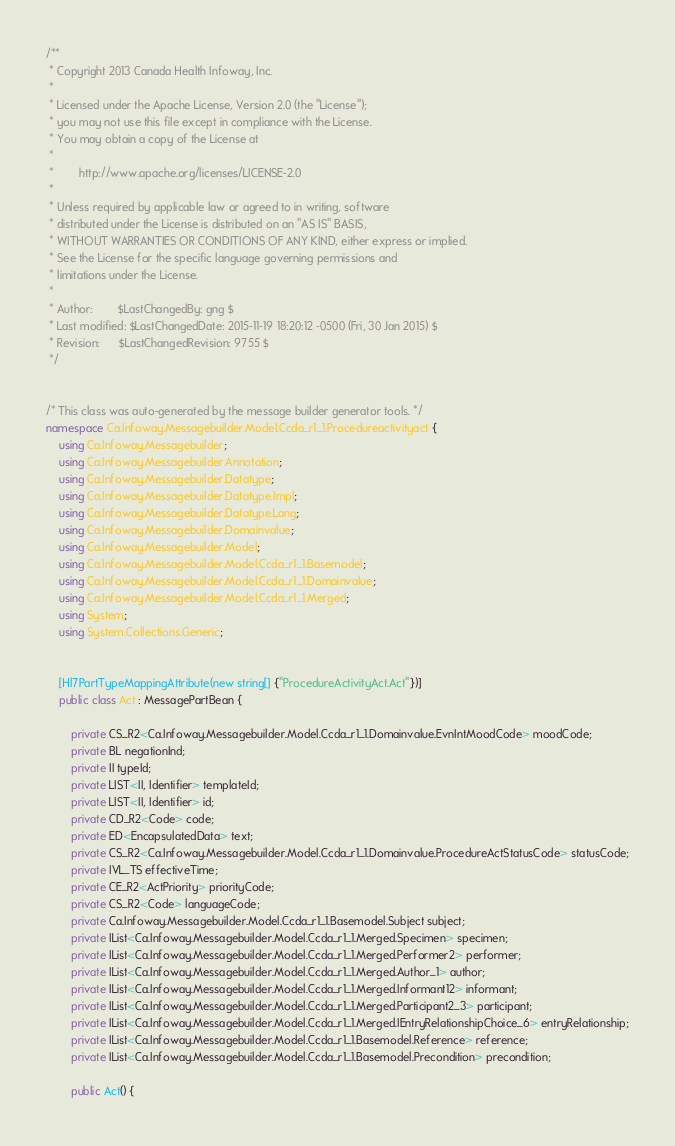Convert code to text. <code><loc_0><loc_0><loc_500><loc_500><_C#_>/**
 * Copyright 2013 Canada Health Infoway, Inc.
 *
 * Licensed under the Apache License, Version 2.0 (the "License");
 * you may not use this file except in compliance with the License.
 * You may obtain a copy of the License at
 *
 *        http://www.apache.org/licenses/LICENSE-2.0
 *
 * Unless required by applicable law or agreed to in writing, software
 * distributed under the License is distributed on an "AS IS" BASIS,
 * WITHOUT WARRANTIES OR CONDITIONS OF ANY KIND, either express or implied.
 * See the License for the specific language governing permissions and
 * limitations under the License.
 *
 * Author:        $LastChangedBy: gng $
 * Last modified: $LastChangedDate: 2015-11-19 18:20:12 -0500 (Fri, 30 Jan 2015) $
 * Revision:      $LastChangedRevision: 9755 $
 */


/* This class was auto-generated by the message builder generator tools. */
namespace Ca.Infoway.Messagebuilder.Model.Ccda_r1_1.Procedureactivityact {
    using Ca.Infoway.Messagebuilder;
    using Ca.Infoway.Messagebuilder.Annotation;
    using Ca.Infoway.Messagebuilder.Datatype;
    using Ca.Infoway.Messagebuilder.Datatype.Impl;
    using Ca.Infoway.Messagebuilder.Datatype.Lang;
    using Ca.Infoway.Messagebuilder.Domainvalue;
    using Ca.Infoway.Messagebuilder.Model;
    using Ca.Infoway.Messagebuilder.Model.Ccda_r1_1.Basemodel;
    using Ca.Infoway.Messagebuilder.Model.Ccda_r1_1.Domainvalue;
    using Ca.Infoway.Messagebuilder.Model.Ccda_r1_1.Merged;
    using System;
    using System.Collections.Generic;


    [Hl7PartTypeMappingAttribute(new string[] {"ProcedureActivityAct.Act"})]
    public class Act : MessagePartBean {

        private CS_R2<Ca.Infoway.Messagebuilder.Model.Ccda_r1_1.Domainvalue.EvnIntMoodCode> moodCode;
        private BL negationInd;
        private II typeId;
        private LIST<II, Identifier> templateId;
        private LIST<II, Identifier> id;
        private CD_R2<Code> code;
        private ED<EncapsulatedData> text;
        private CS_R2<Ca.Infoway.Messagebuilder.Model.Ccda_r1_1.Domainvalue.ProcedureActStatusCode> statusCode;
        private IVL_TS effectiveTime;
        private CE_R2<ActPriority> priorityCode;
        private CS_R2<Code> languageCode;
        private Ca.Infoway.Messagebuilder.Model.Ccda_r1_1.Basemodel.Subject subject;
        private IList<Ca.Infoway.Messagebuilder.Model.Ccda_r1_1.Merged.Specimen> specimen;
        private IList<Ca.Infoway.Messagebuilder.Model.Ccda_r1_1.Merged.Performer2> performer;
        private IList<Ca.Infoway.Messagebuilder.Model.Ccda_r1_1.Merged.Author_1> author;
        private IList<Ca.Infoway.Messagebuilder.Model.Ccda_r1_1.Merged.Informant12> informant;
        private IList<Ca.Infoway.Messagebuilder.Model.Ccda_r1_1.Merged.Participant2_3> participant;
        private IList<Ca.Infoway.Messagebuilder.Model.Ccda_r1_1.Merged.IEntryRelationshipChoice_6> entryRelationship;
        private IList<Ca.Infoway.Messagebuilder.Model.Ccda_r1_1.Basemodel.Reference> reference;
        private IList<Ca.Infoway.Messagebuilder.Model.Ccda_r1_1.Basemodel.Precondition> precondition;

        public Act() {</code> 